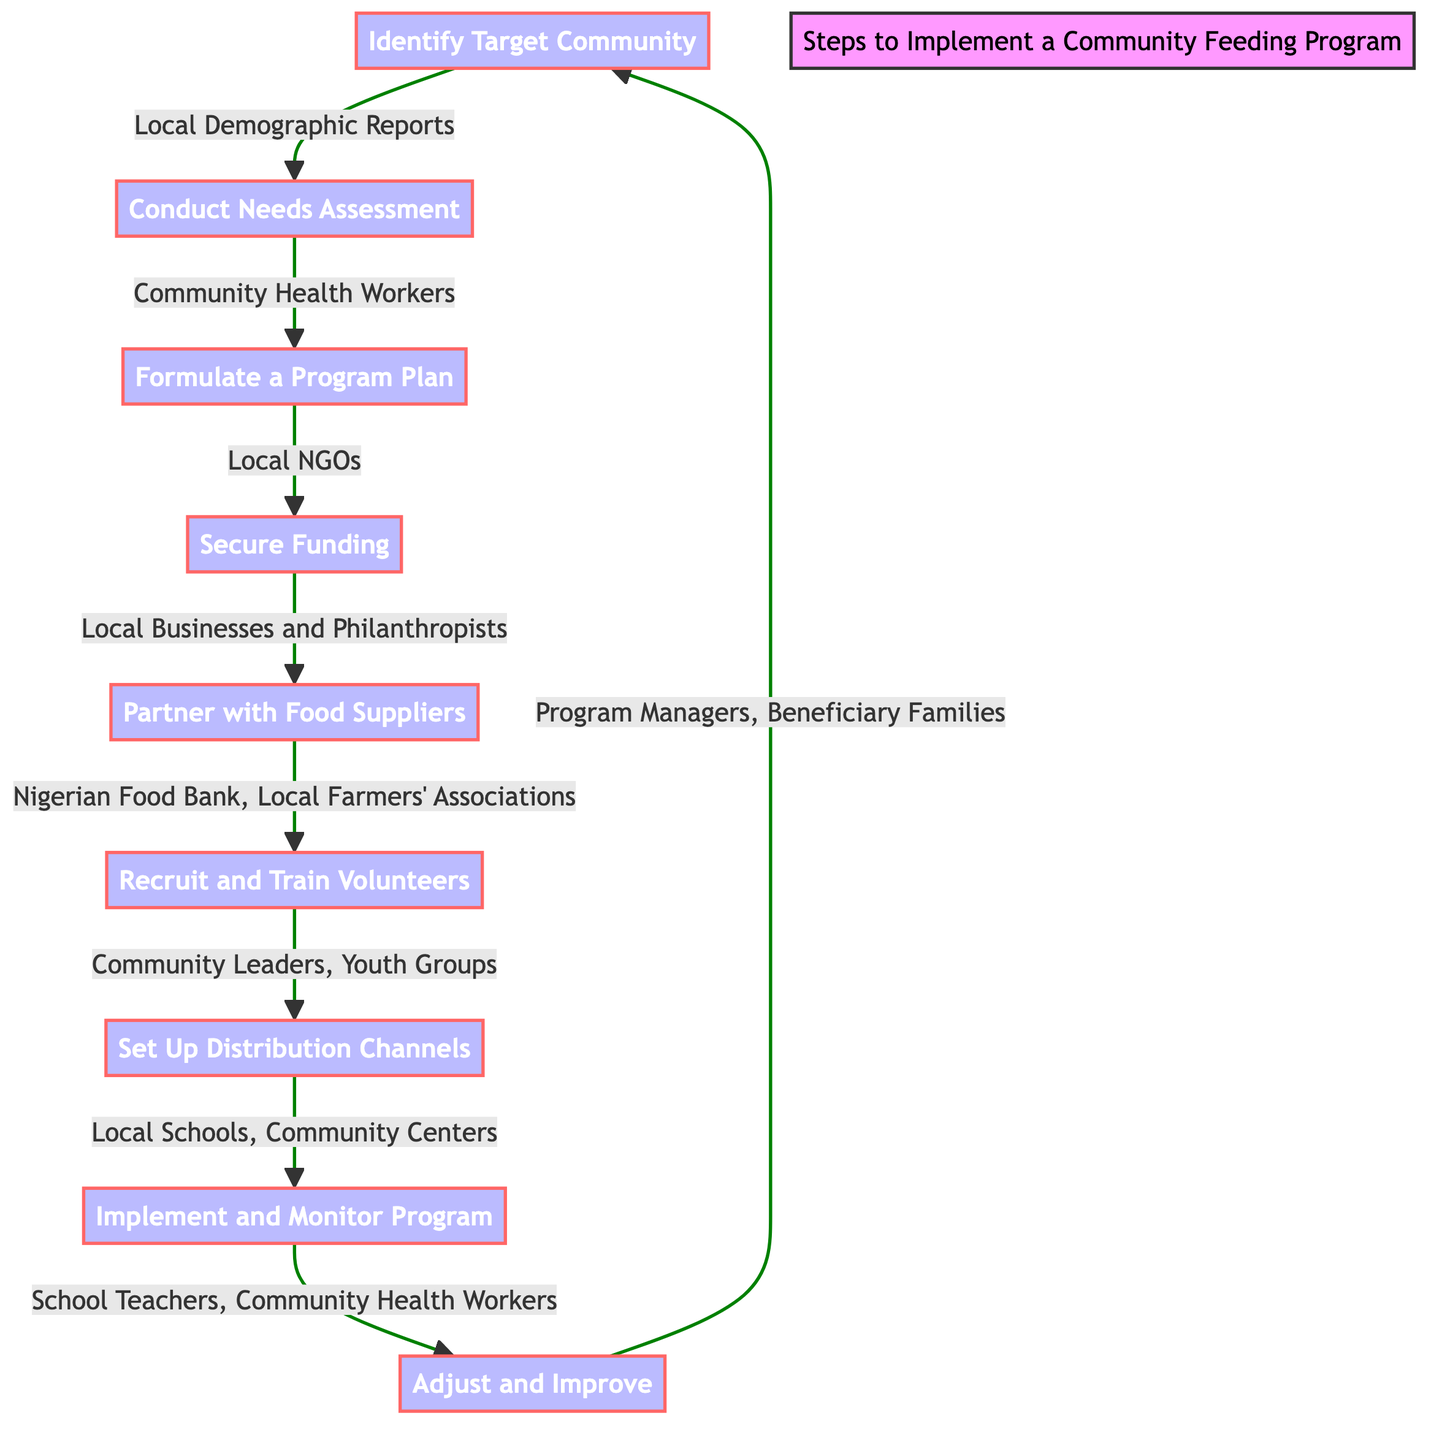What is the first step in the diagram? The first step in the diagram is "Identify Target Community," which is the starting node in the flowchart.
Answer: Identify Target Community Which entity is associated with conducting the needs assessment? The entity linked to conducting the needs assessment is "Community Health Workers," as indicated in the diagram.
Answer: Community Health Workers How many total steps are in the feeding program process? The diagram includes a total of nine steps, counting from identifying the target community to adjusting and improving the program.
Answer: Nine steps Which two entities are involved in recruiting and training volunteers? "Community Leaders" and "Youth Groups" are the two entities involved in this process, as shown in the flowchart.
Answer: Community Leaders, Youth Groups What is the purpose of the "Set Up Distribution Channels" step? The purpose of this step is to organize distribution points and ensure that they are easily accessible for the community members.
Answer: Organize distribution points What step follows "Secure Funding" in the program? The step that follows "Secure Funding" is "Partner with Food Suppliers," indicating a direct progression from funding to sourcing food.
Answer: Partner with Food Suppliers Which entities are critical for monitoring the program's effectiveness? The critical entities for monitoring the program are "School Teachers" and "Community Health Workers," as they are responsible for feedback and oversight.
Answer: School Teachers, Community Health Workers What is a required activity in the "Adjust and Improve" step? A required activity in this step is to continuously improve the program through feedback and periodic evaluations.
Answer: Improve through feedback Which stakeholders are involved in the “Implement and Monitor Program” step? The stakeholders involved in this step are "School Teachers" and "Community Health Workers," who play a key role in implementing and monitoring the initiative.
Answer: School Teachers, Community Health Workers 